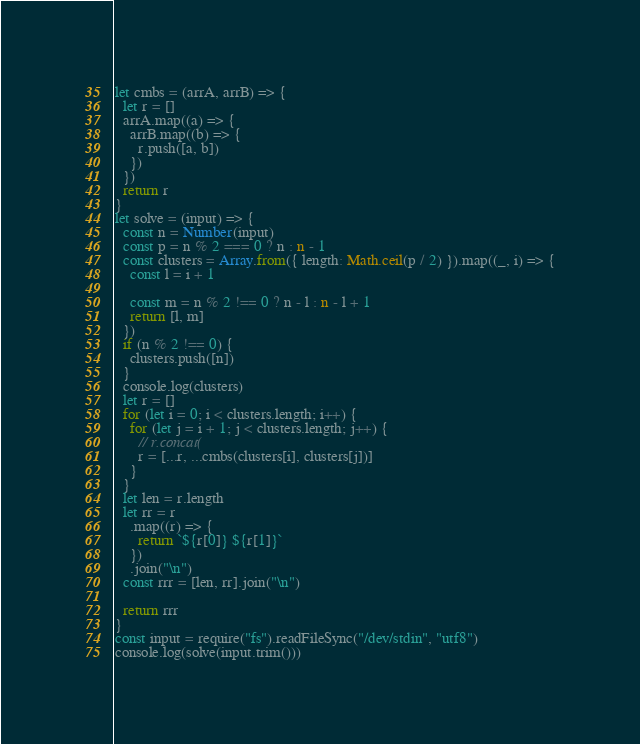Convert code to text. <code><loc_0><loc_0><loc_500><loc_500><_TypeScript_>let cmbs = (arrA, arrB) => {
  let r = []
  arrA.map((a) => {
    arrB.map((b) => {
      r.push([a, b])
    })
  })
  return r
}
let solve = (input) => {
  const n = Number(input)
  const p = n % 2 === 0 ? n : n - 1
  const clusters = Array.from({ length: Math.ceil(p / 2) }).map((_, i) => {
    const l = i + 1

    const m = n % 2 !== 0 ? n - l : n - l + 1
    return [l, m]
  })
  if (n % 2 !== 0) {
    clusters.push([n])
  }
  console.log(clusters)
  let r = []
  for (let i = 0; i < clusters.length; i++) {
    for (let j = i + 1; j < clusters.length; j++) {
      // r.concat(
      r = [...r, ...cmbs(clusters[i], clusters[j])]
    }
  }
  let len = r.length
  let rr = r
    .map((r) => {
      return `${r[0]} ${r[1]}`
    })
    .join("\n")
  const rrr = [len, rr].join("\n")

  return rrr
}
const input = require("fs").readFileSync("/dev/stdin", "utf8")
console.log(solve(input.trim()))
</code> 